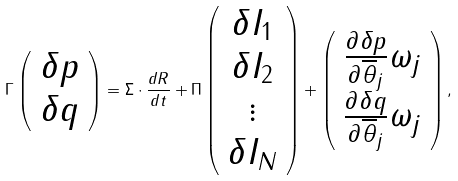<formula> <loc_0><loc_0><loc_500><loc_500>\Gamma \left ( \begin{array} { c } \delta p \\ \delta q \end{array} \right ) = \Sigma \cdot \frac { d R } { d t } + \Pi \left ( \begin{array} { c } \delta I _ { 1 } \\ \delta I _ { 2 } \\ \vdots \\ \delta I _ { N } \end{array} \right ) + \left ( \begin{array} { c } \frac { \partial \delta p } { \partial \overline { \theta } _ { j } } \omega _ { j } \\ \frac { \partial \delta q } { \partial \overline { \theta } _ { j } } \omega _ { j } \end{array} \right ) ,</formula> 